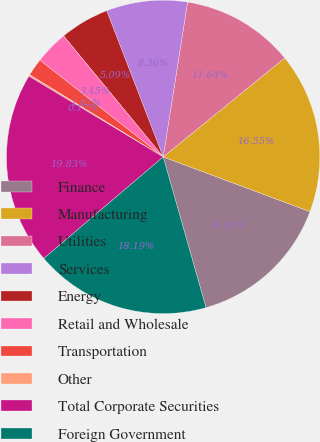Convert chart. <chart><loc_0><loc_0><loc_500><loc_500><pie_chart><fcel>Finance<fcel>Manufacturing<fcel>Utilities<fcel>Services<fcel>Energy<fcel>Retail and Wholesale<fcel>Transportation<fcel>Other<fcel>Total Corporate Securities<fcel>Foreign Government<nl><fcel>14.91%<fcel>16.55%<fcel>11.64%<fcel>8.36%<fcel>5.09%<fcel>3.45%<fcel>1.81%<fcel>0.17%<fcel>19.83%<fcel>18.19%<nl></chart> 